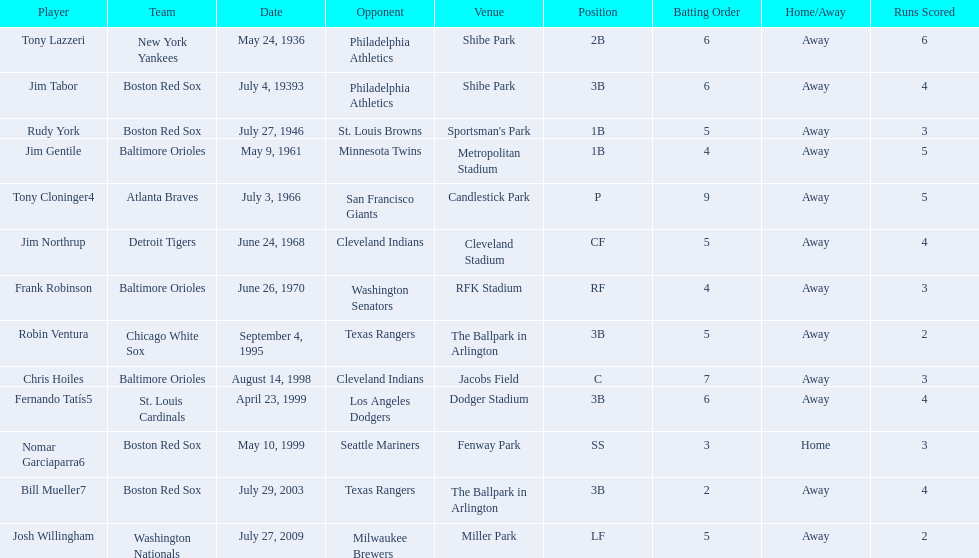What are the dates? May 24, 1936, July 4, 19393, July 27, 1946, May 9, 1961, July 3, 1966, June 24, 1968, June 26, 1970, September 4, 1995, August 14, 1998, April 23, 1999, May 10, 1999, July 29, 2003, July 27, 2009. Which date is in 1936? May 24, 1936. What player is listed for this date? Tony Lazzeri. 